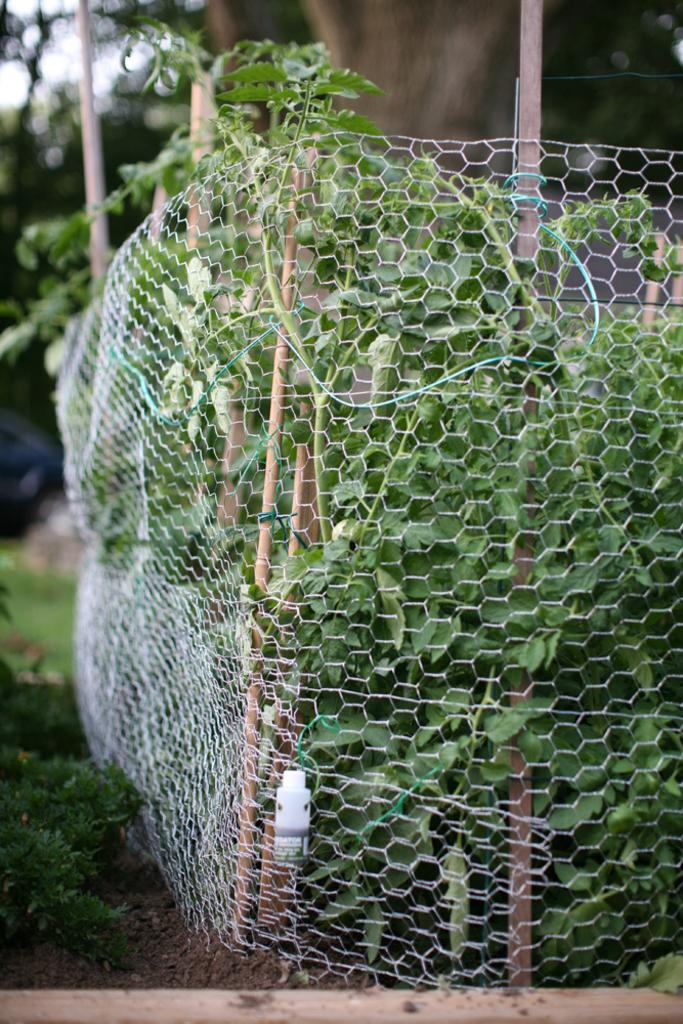What can be seen in the image that might be used for support or safety? There is a railing in the image that might be used for support or safety. What type of natural scenery is visible in the background of the image? There are trees in the background of the image. What color are the trees in the image? The trees are green in color. What part of the natural environment is visible in the image? The sky is visible in the image. What color is the sky in the image? The sky is white in color. How does the sugar affect the growth of the trees in the image? There is no sugar present in the image, so its effect on the trees cannot be determined. 